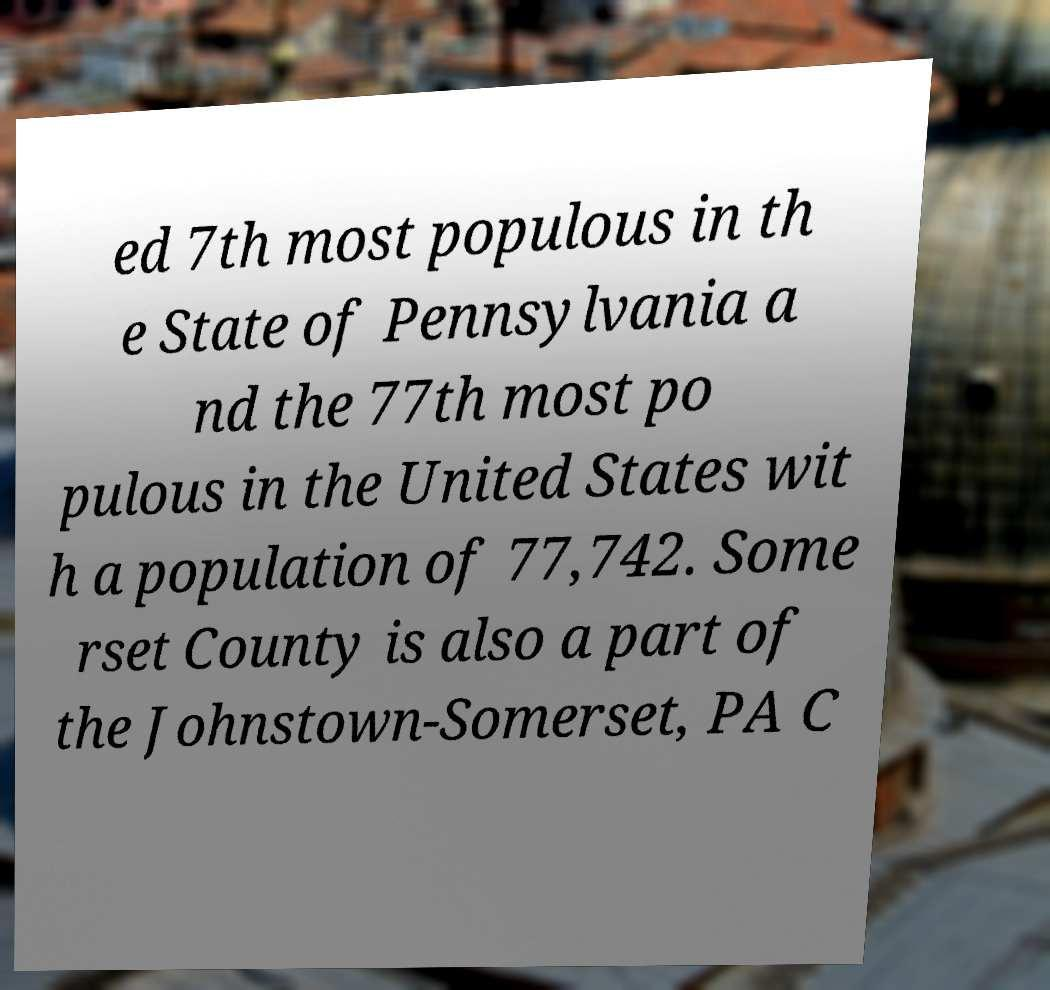What messages or text are displayed in this image? I need them in a readable, typed format. ed 7th most populous in th e State of Pennsylvania a nd the 77th most po pulous in the United States wit h a population of 77,742. Some rset County is also a part of the Johnstown-Somerset, PA C 